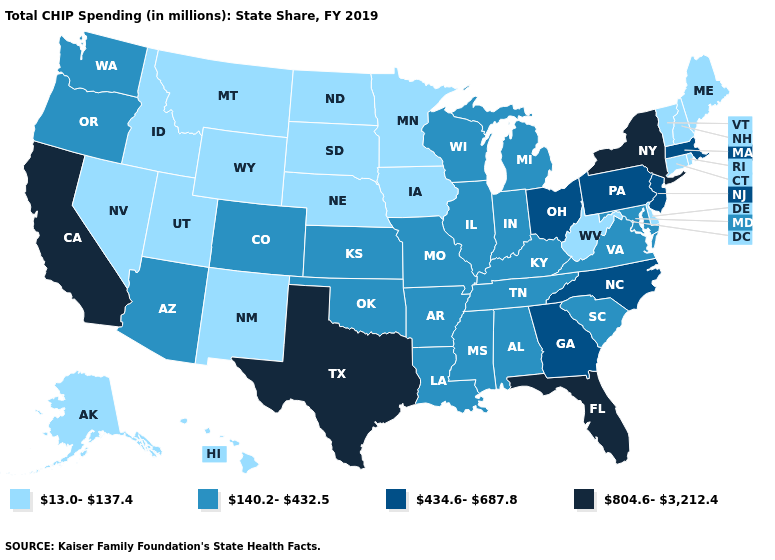Name the states that have a value in the range 13.0-137.4?
Short answer required. Alaska, Connecticut, Delaware, Hawaii, Idaho, Iowa, Maine, Minnesota, Montana, Nebraska, Nevada, New Hampshire, New Mexico, North Dakota, Rhode Island, South Dakota, Utah, Vermont, West Virginia, Wyoming. What is the value of New York?
Write a very short answer. 804.6-3,212.4. Name the states that have a value in the range 804.6-3,212.4?
Be succinct. California, Florida, New York, Texas. What is the lowest value in the Northeast?
Short answer required. 13.0-137.4. How many symbols are there in the legend?
Keep it brief. 4. Is the legend a continuous bar?
Keep it brief. No. Name the states that have a value in the range 434.6-687.8?
Answer briefly. Georgia, Massachusetts, New Jersey, North Carolina, Ohio, Pennsylvania. Among the states that border Michigan , does Ohio have the lowest value?
Write a very short answer. No. What is the value of Alaska?
Give a very brief answer. 13.0-137.4. What is the value of Nevada?
Short answer required. 13.0-137.4. Among the states that border New Hampshire , which have the lowest value?
Write a very short answer. Maine, Vermont. Which states have the lowest value in the USA?
Keep it brief. Alaska, Connecticut, Delaware, Hawaii, Idaho, Iowa, Maine, Minnesota, Montana, Nebraska, Nevada, New Hampshire, New Mexico, North Dakota, Rhode Island, South Dakota, Utah, Vermont, West Virginia, Wyoming. What is the value of Connecticut?
Be succinct. 13.0-137.4. Does Colorado have a lower value than New York?
Be succinct. Yes. Does Texas have the highest value in the South?
Write a very short answer. Yes. 